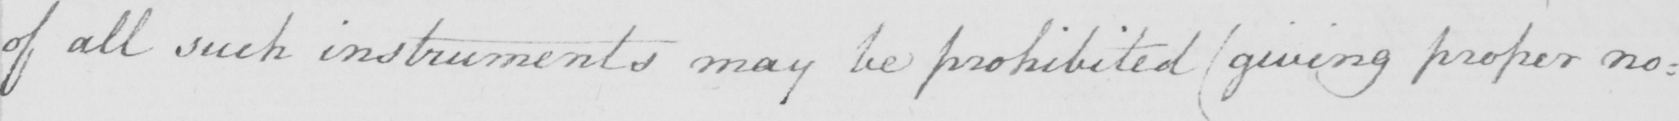Can you tell me what this handwritten text says? of all such instruments may be prohibited  ( giving proper no= 